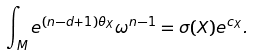Convert formula to latex. <formula><loc_0><loc_0><loc_500><loc_500>\int _ { M } e ^ { ( n - d + 1 ) \theta _ { X } } \omega ^ { n - 1 } = \sigma ( X ) e ^ { c _ { X } } .</formula> 